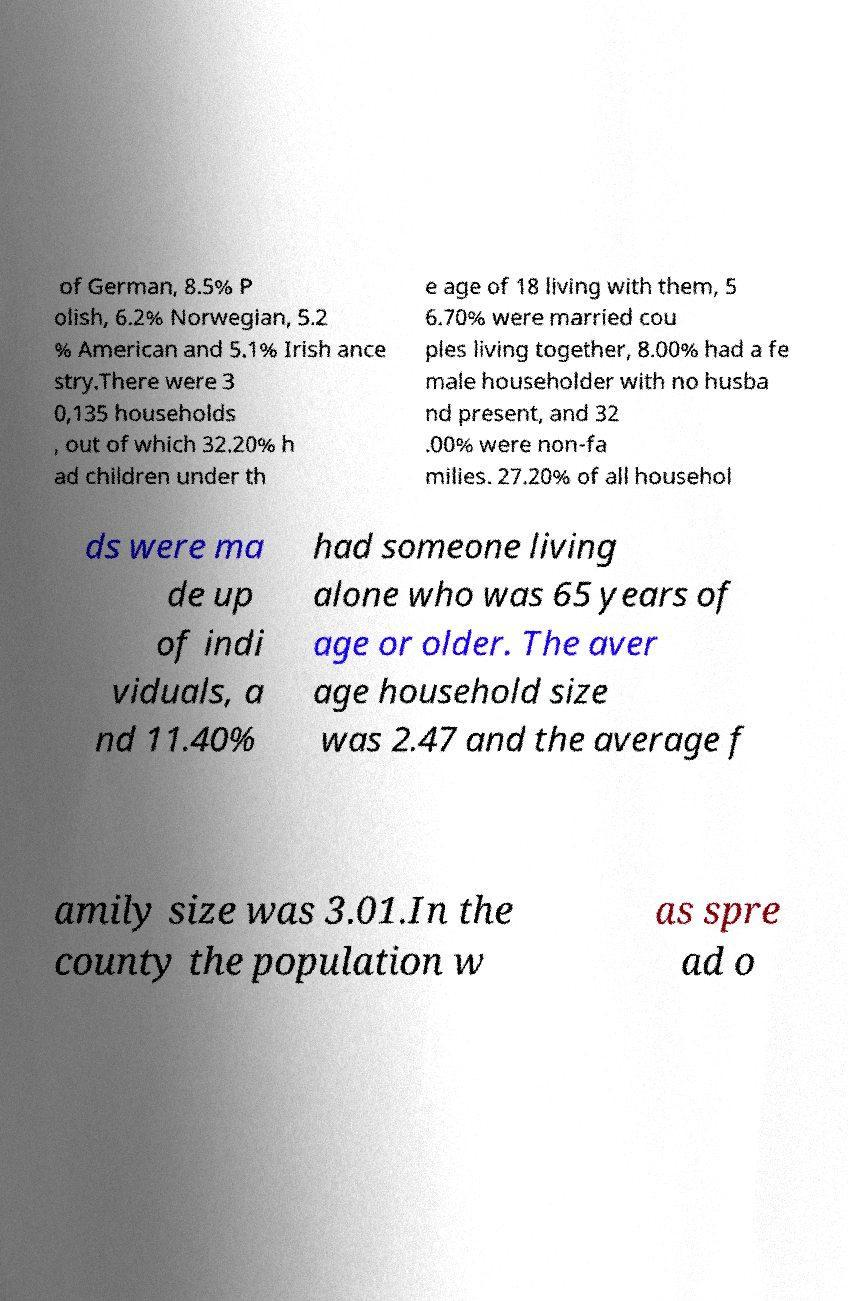Please read and relay the text visible in this image. What does it say? of German, 8.5% P olish, 6.2% Norwegian, 5.2 % American and 5.1% Irish ance stry.There were 3 0,135 households , out of which 32.20% h ad children under th e age of 18 living with them, 5 6.70% were married cou ples living together, 8.00% had a fe male householder with no husba nd present, and 32 .00% were non-fa milies. 27.20% of all househol ds were ma de up of indi viduals, a nd 11.40% had someone living alone who was 65 years of age or older. The aver age household size was 2.47 and the average f amily size was 3.01.In the county the population w as spre ad o 